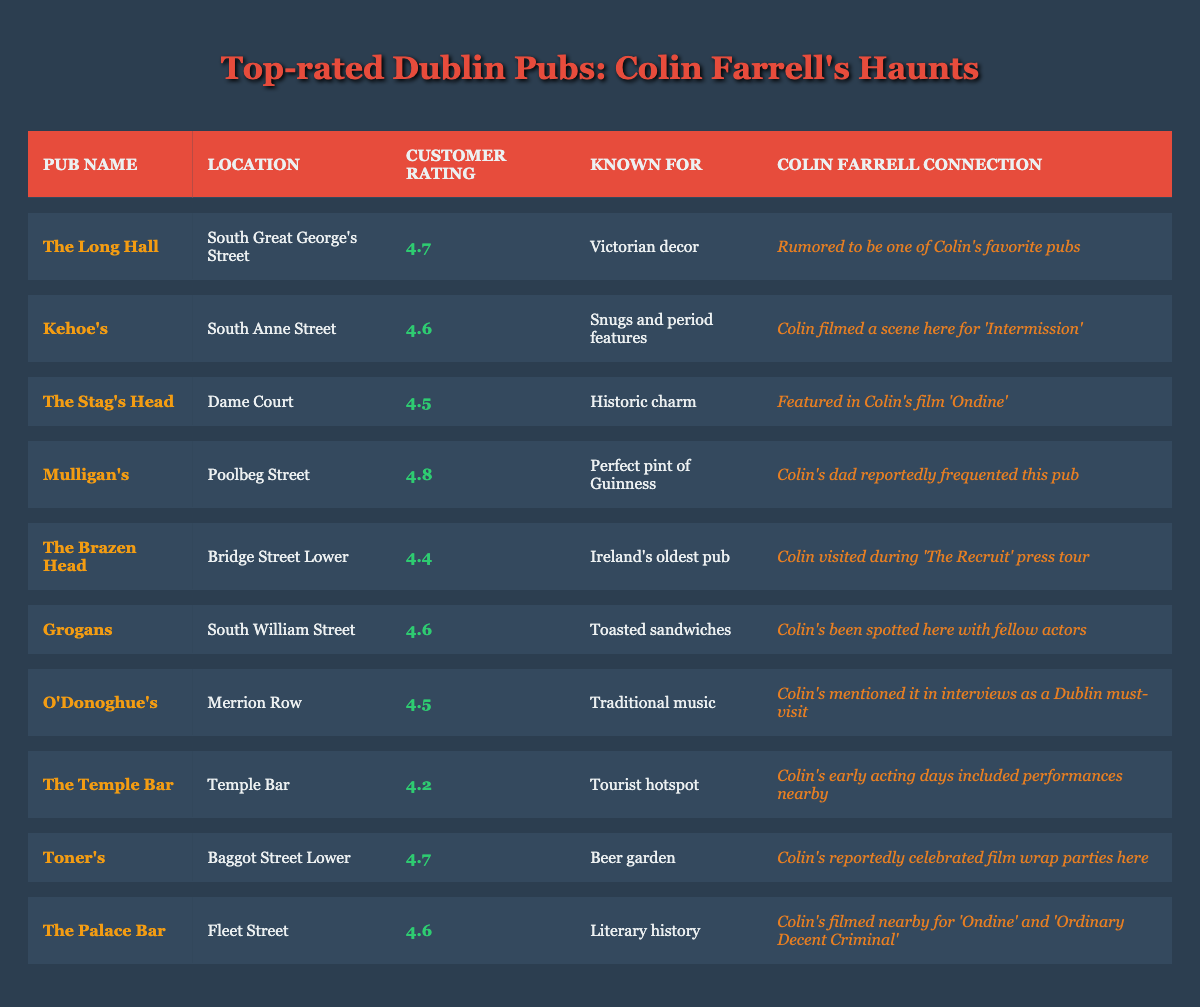What is the customer rating of Mulligan's? The table shows that Mulligan's has a customer rating of 4.8, which is specifically listed in the "Customer Rating" column next to its name.
Answer: 4.8 Which pub is known for its Victorian decor? The table indicates that The Long Hall is known for its Victorian decor, as stated in the "Known For" column next to it.
Answer: The Long Hall Are there any pubs on South Great George's Street? Yes, The Long Hall is located on South Great George's Street, as per the "Location" column.
Answer: Yes Which pub has the lowest customer rating? Looking across the "Customer Rating" column, The Temple Bar has the lowest rating of 4.2, making it the lowest rated pub in the table.
Answer: The Temple Bar What is the average customer rating of all pubs listed? To calculate the average, we sum all the ratings (4.7 + 4.6 + 4.5 + 4.8 + 4.4 + 4.6 + 4.5 + 4.2 + 4.7 + 4.6 = 46.6) and divide by the number of pubs (10), resulting in an average rating of 4.66.
Answer: 4.66 Which pub is associated with Colin's dad? The table notes that Mulligan's is associated with Colin's dad, as mentioned in the "Colin Farrell Connection" column.
Answer: Mulligan's Is there a pub that Colin Farrell frequented connected to traditional music? Yes, O'Donoghue's is noted in the table as a pub connected to traditional music, according to the "Known For" column.
Answer: Yes How many pubs are located on South Anne Street? The table indicates that there is only one pub on South Anne Street, which is Kehoe's, as listed under the "Location" column.
Answer: One What did Colin do at Grogans according to the table? The table mentions that Colin has been spotted at Grogans with fellow actors, which is noted in the "Colin Farrell Connection" column.
Answer: He was spotted there with fellow actors 